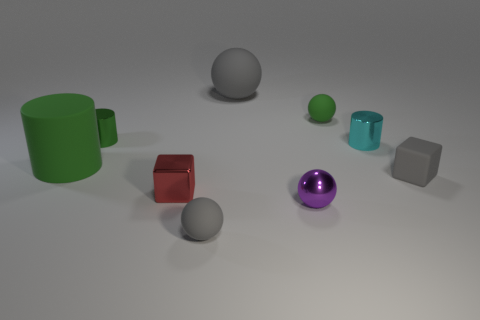Can you describe the color and shape diversity among the objects presented in the image? Certainly! The image showcases a variety of geometric shapes including cylinders, spheres, and cubes. The colors are equally diverse, featuring vibrant hues such as green, red, cyan, and purple along with neutral tones of gray. 